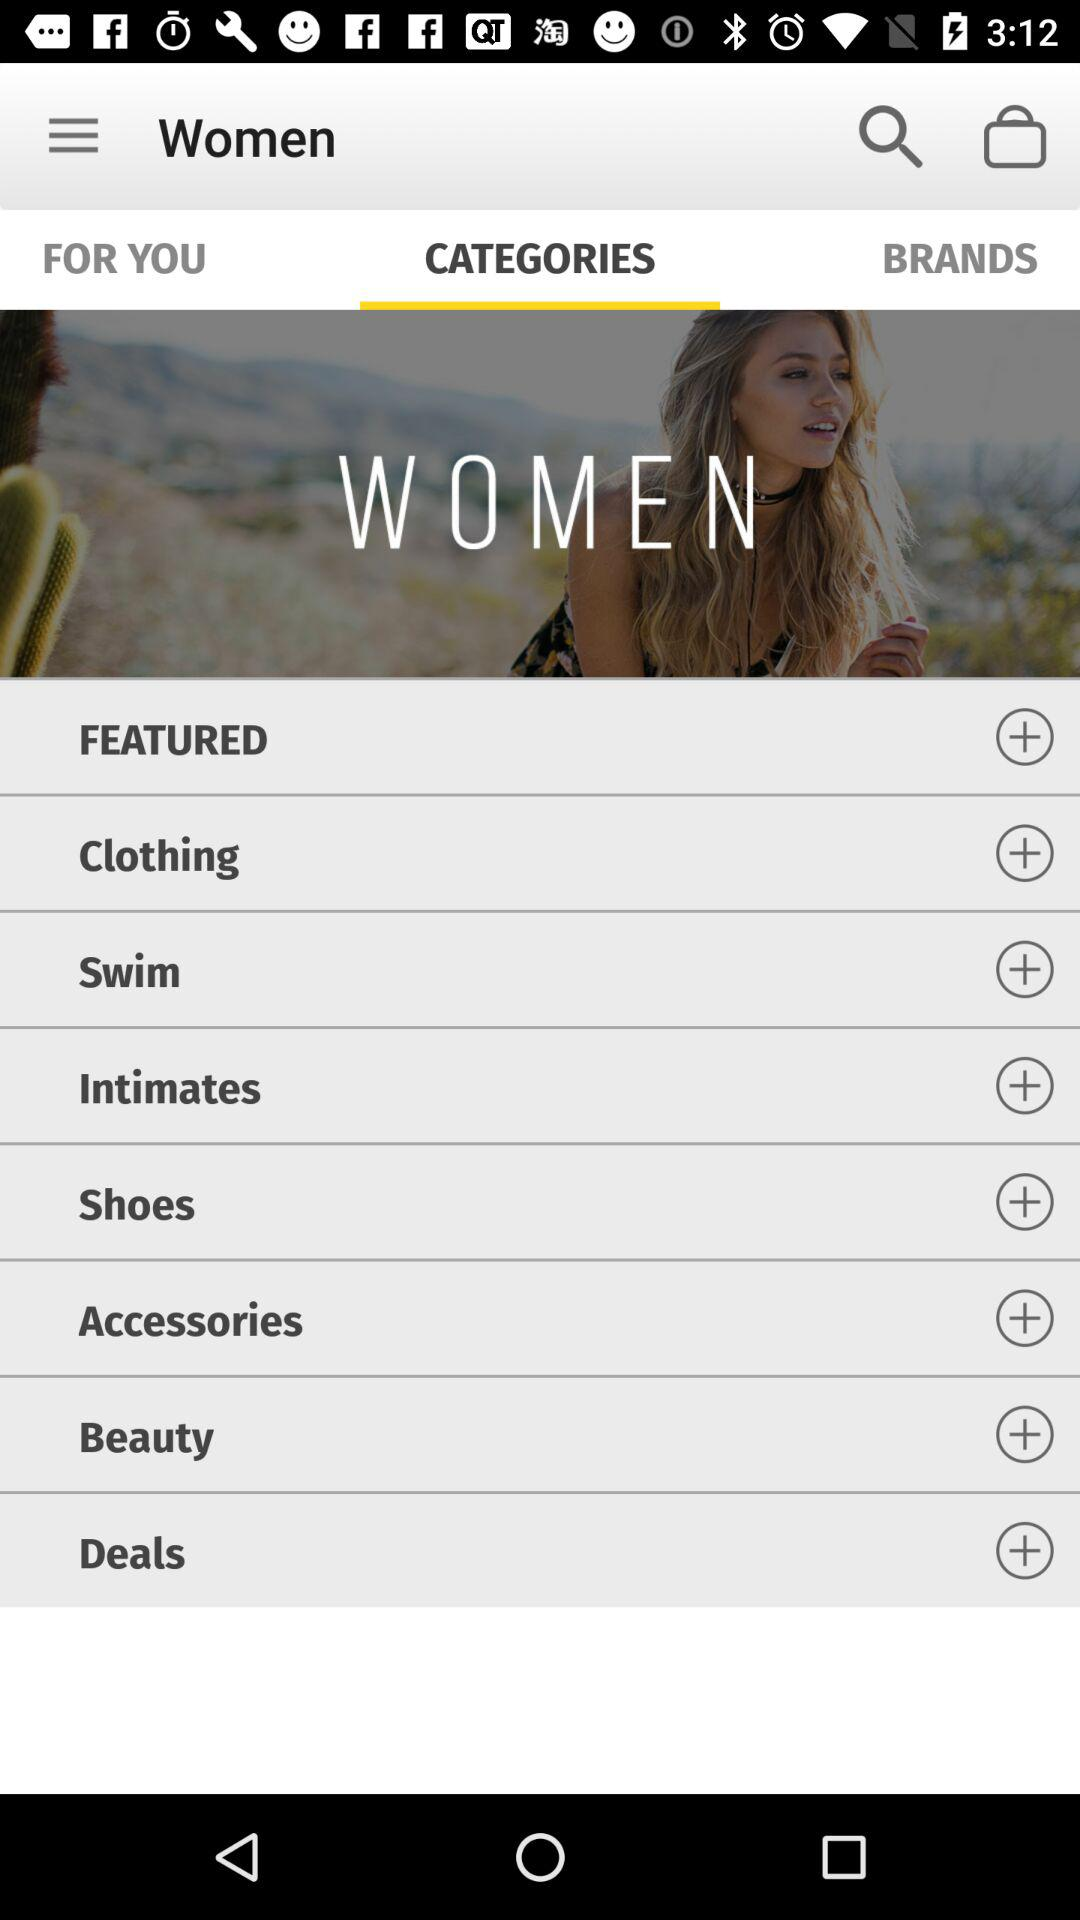Which tab is open? The open tab is "CATEGORIES". 